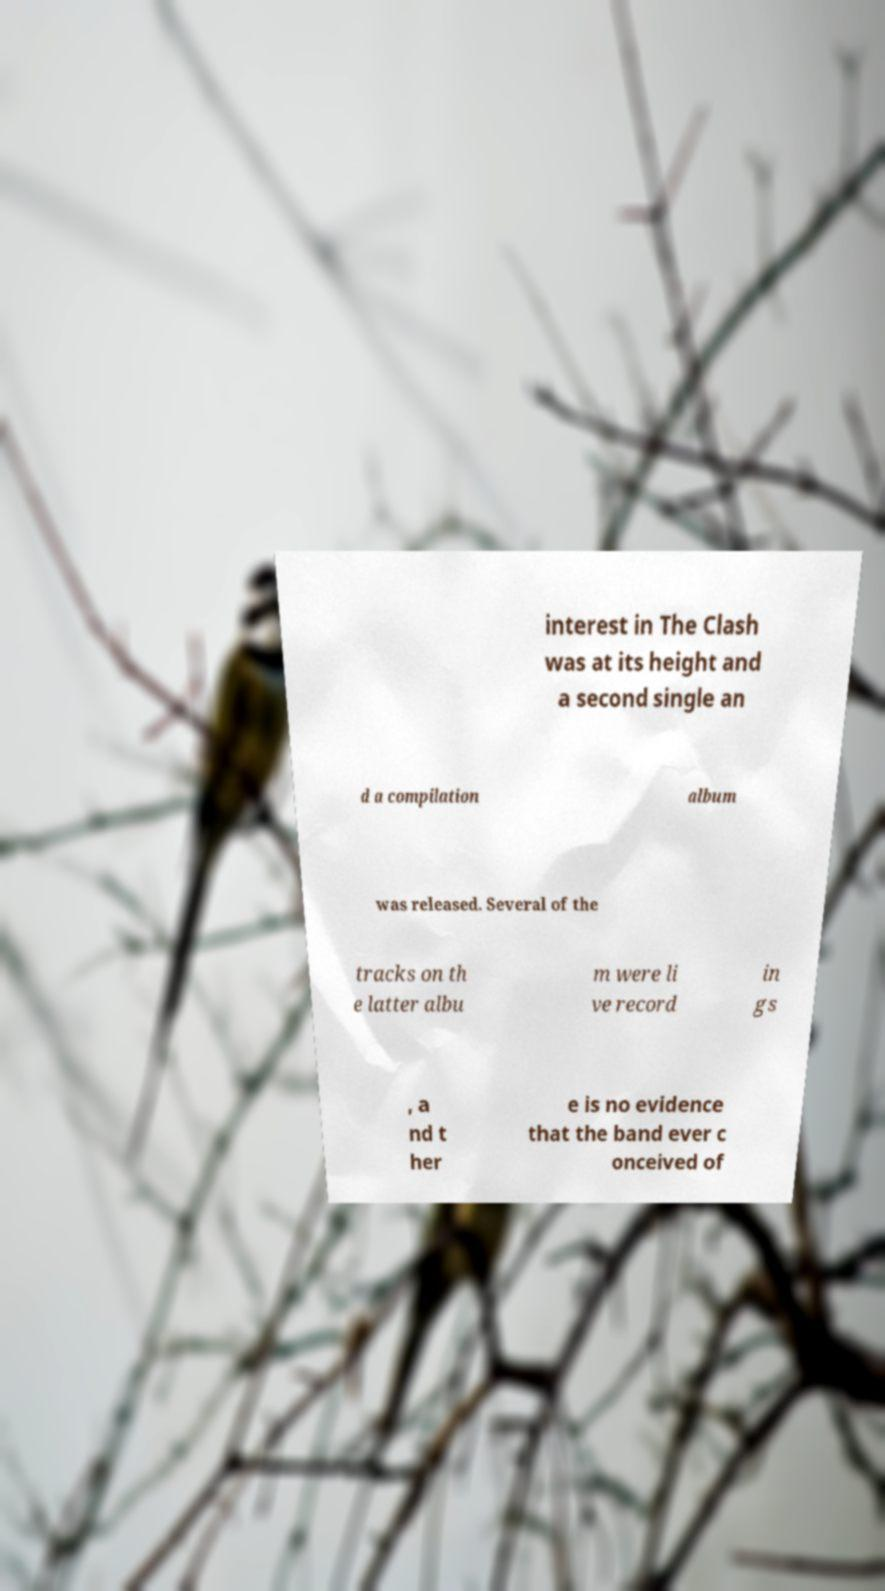Could you assist in decoding the text presented in this image and type it out clearly? interest in The Clash was at its height and a second single an d a compilation album was released. Several of the tracks on th e latter albu m were li ve record in gs , a nd t her e is no evidence that the band ever c onceived of 